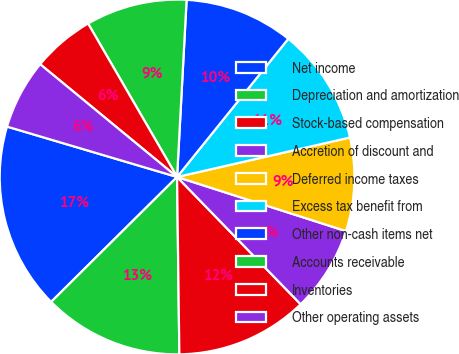Convert chart. <chart><loc_0><loc_0><loc_500><loc_500><pie_chart><fcel>Net income<fcel>Depreciation and amortization<fcel>Stock-based compensation<fcel>Accretion of discount and<fcel>Deferred income taxes<fcel>Excess tax benefit from<fcel>Other non-cash items net<fcel>Accounts receivable<fcel>Inventories<fcel>Other operating assets<nl><fcel>17.02%<fcel>12.77%<fcel>12.06%<fcel>7.8%<fcel>8.51%<fcel>10.64%<fcel>9.93%<fcel>9.22%<fcel>5.67%<fcel>6.38%<nl></chart> 